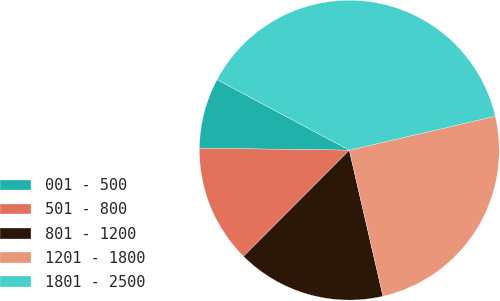Convert chart to OTSL. <chart><loc_0><loc_0><loc_500><loc_500><pie_chart><fcel>001 - 500<fcel>501 - 800<fcel>801 - 1200<fcel>1201 - 1800<fcel>1801 - 2500<nl><fcel>7.59%<fcel>12.74%<fcel>16.08%<fcel>25.03%<fcel>38.57%<nl></chart> 